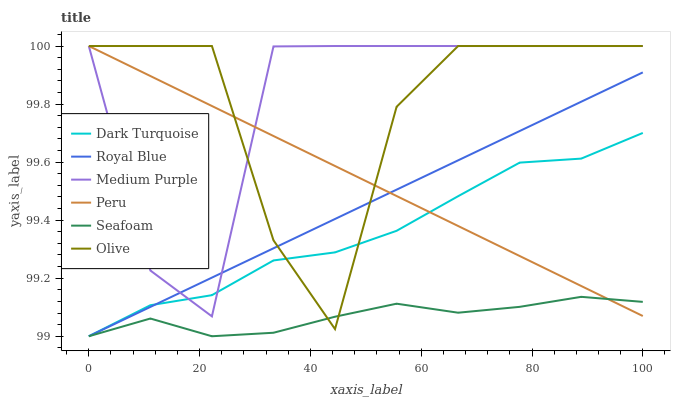Does Seafoam have the minimum area under the curve?
Answer yes or no. Yes. Does Medium Purple have the maximum area under the curve?
Answer yes or no. Yes. Does Medium Purple have the minimum area under the curve?
Answer yes or no. No. Does Seafoam have the maximum area under the curve?
Answer yes or no. No. Is Royal Blue the smoothest?
Answer yes or no. Yes. Is Olive the roughest?
Answer yes or no. Yes. Is Seafoam the smoothest?
Answer yes or no. No. Is Seafoam the roughest?
Answer yes or no. No. Does Dark Turquoise have the lowest value?
Answer yes or no. Yes. Does Medium Purple have the lowest value?
Answer yes or no. No. Does Olive have the highest value?
Answer yes or no. Yes. Does Seafoam have the highest value?
Answer yes or no. No. Is Seafoam less than Medium Purple?
Answer yes or no. Yes. Is Medium Purple greater than Seafoam?
Answer yes or no. Yes. Does Royal Blue intersect Medium Purple?
Answer yes or no. Yes. Is Royal Blue less than Medium Purple?
Answer yes or no. No. Is Royal Blue greater than Medium Purple?
Answer yes or no. No. Does Seafoam intersect Medium Purple?
Answer yes or no. No. 